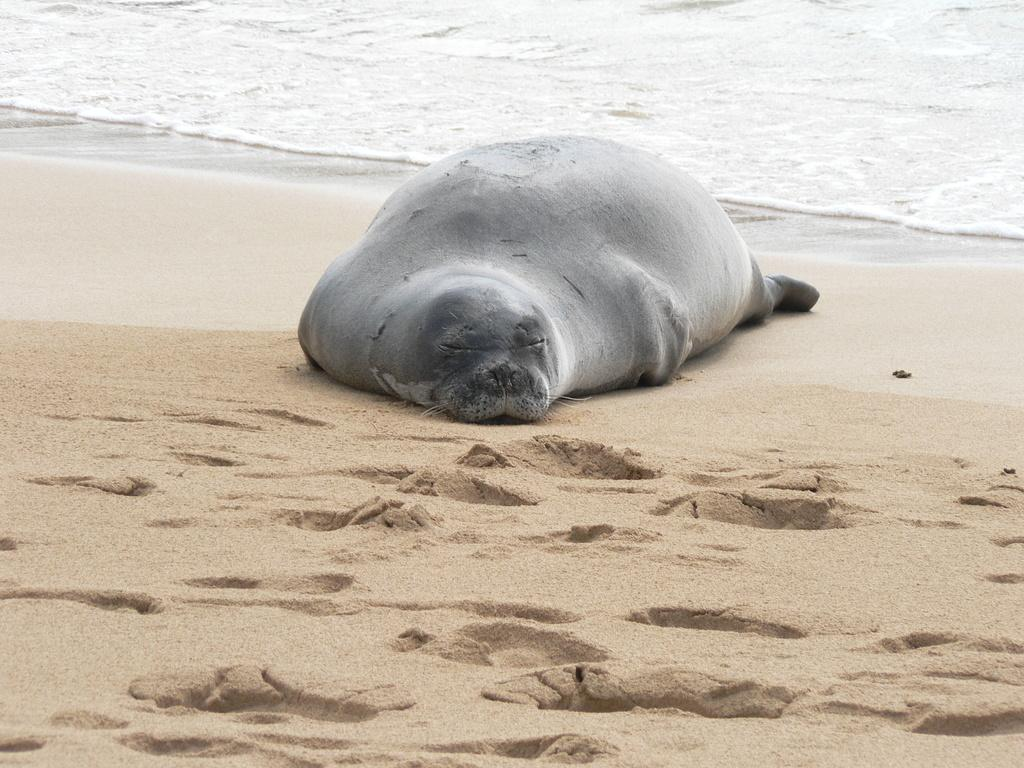What animal is the main subject of the image? There is a harbor seal in the center of the image. What type of environment is visible in the image? The ocean is visible at the top of the image. What type of terrain can be seen in the background of the image? There is soil visible in the background of the image. Can you tell me how many frogs are hiding in the cellar in the image? There are no frogs or cellars present in the image; it features a harbor seal in the ocean with soil visible in the background. 